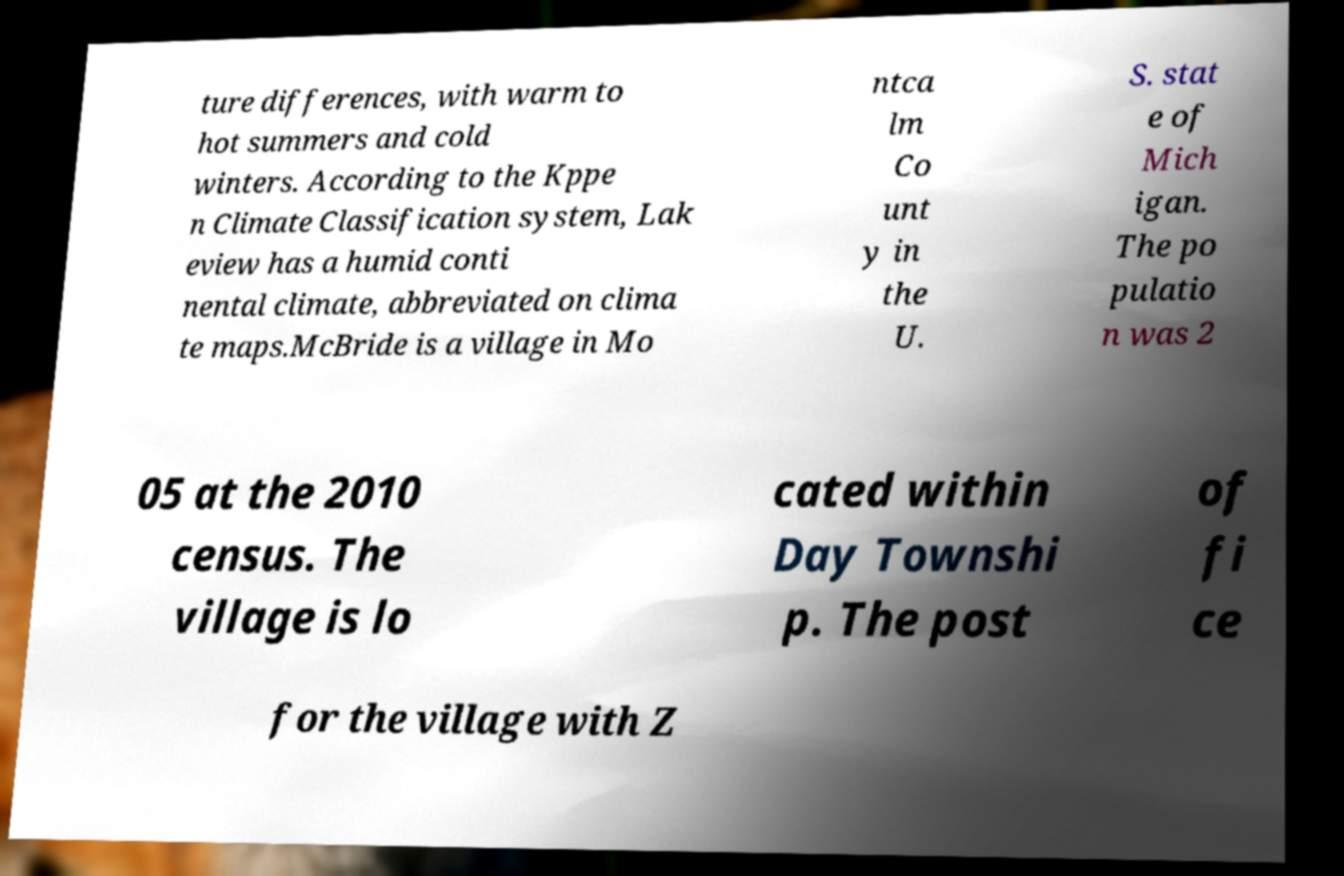Please identify and transcribe the text found in this image. ture differences, with warm to hot summers and cold winters. According to the Kppe n Climate Classification system, Lak eview has a humid conti nental climate, abbreviated on clima te maps.McBride is a village in Mo ntca lm Co unt y in the U. S. stat e of Mich igan. The po pulatio n was 2 05 at the 2010 census. The village is lo cated within Day Townshi p. The post of fi ce for the village with Z 